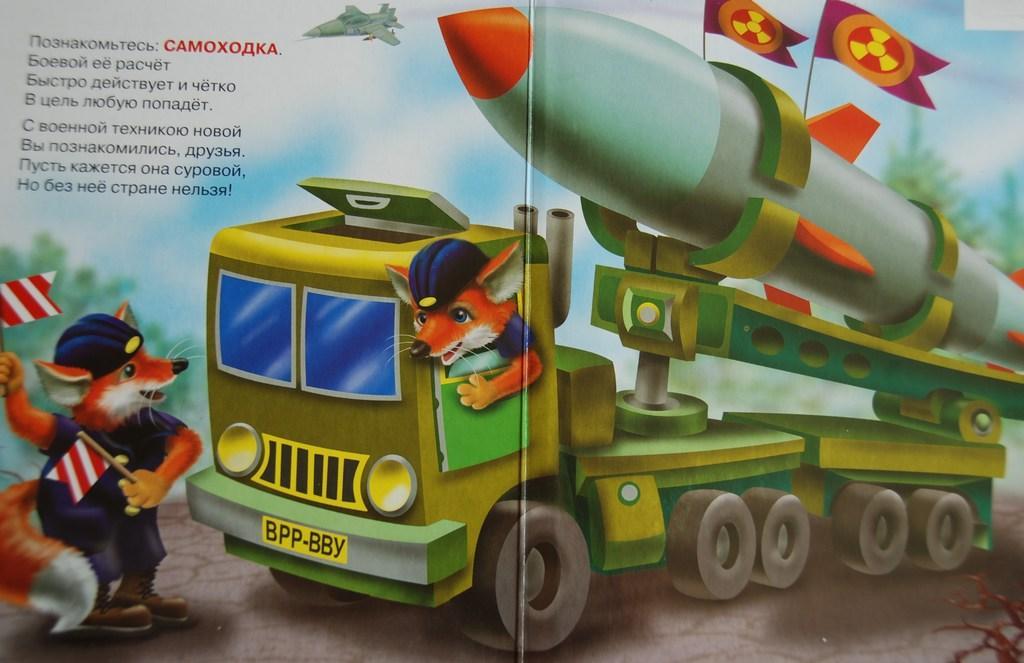Can you describe this image briefly? In this image, we can see a poster and text. Here we can see vehicle, animals, flags and aircraft. 